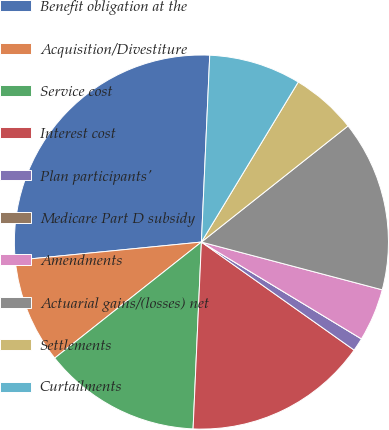Convert chart to OTSL. <chart><loc_0><loc_0><loc_500><loc_500><pie_chart><fcel>Benefit obligation at the<fcel>Acquisition/Divestiture<fcel>Service cost<fcel>Interest cost<fcel>Plan participants'<fcel>Medicare Part D subsidy<fcel>Amendments<fcel>Actuarial gains/(losses) net<fcel>Settlements<fcel>Curtailments<nl><fcel>27.27%<fcel>9.09%<fcel>13.64%<fcel>15.91%<fcel>1.14%<fcel>0.0%<fcel>4.55%<fcel>14.77%<fcel>5.68%<fcel>7.95%<nl></chart> 